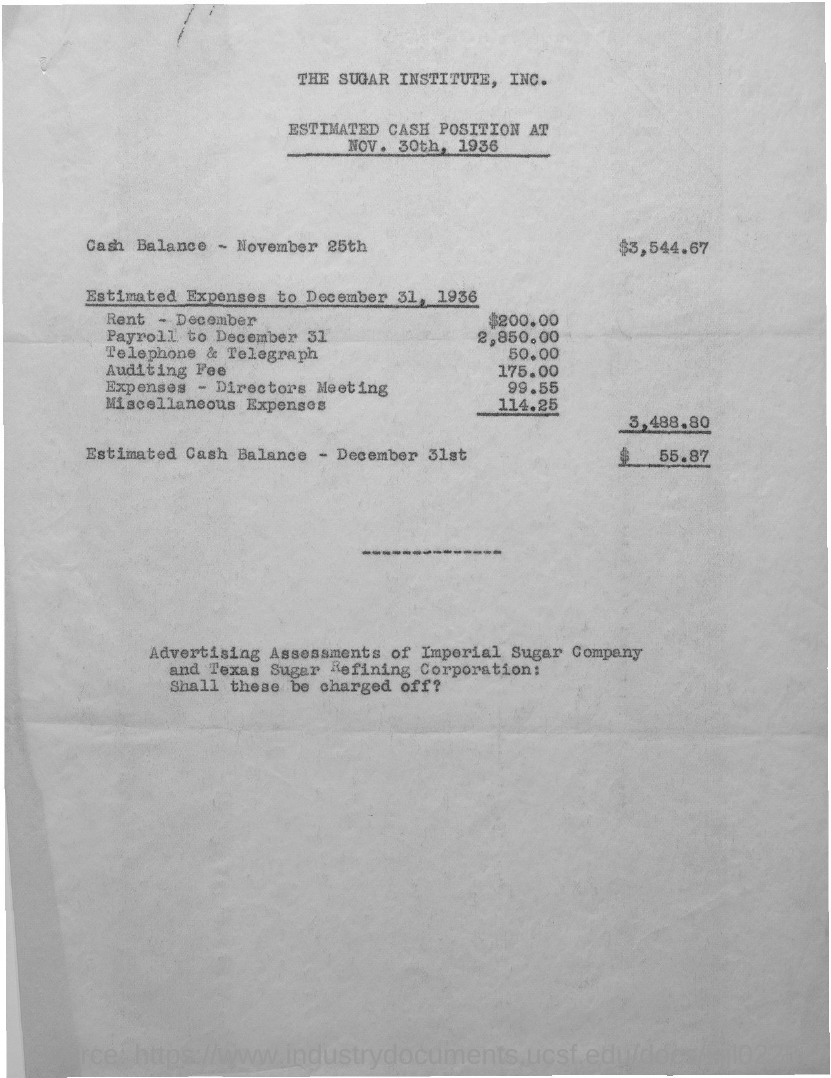Point out several critical features in this image. The cash balance on November 25th was 3,544.67. The estimated cash balance on December 31st is estimated to be $55.87. 